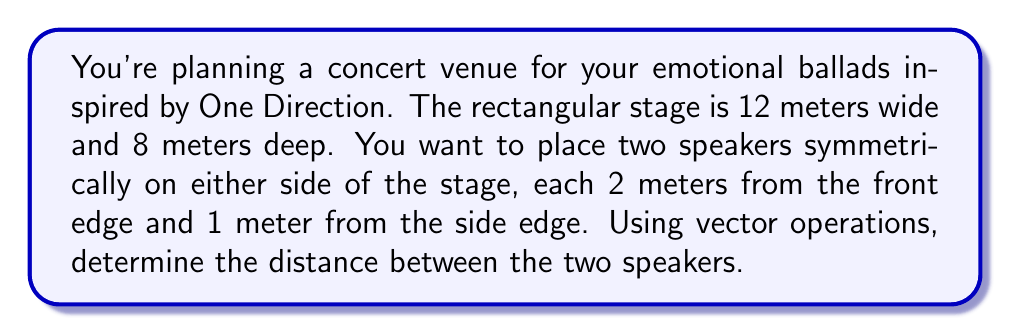Help me with this question. Let's approach this step-by-step using vector operations:

1) First, we need to define our coordinate system. Let's place the origin (0,0) at the front left corner of the stage.

2) Now, we can represent the positions of the two speakers as vectors:
   Left speaker: $\vec{v_1} = (1, 2)$
   Right speaker: $\vec{v_2} = (11, 2)$

3) To find the distance between the speakers, we need to find the vector that connects them:
   $\vec{d} = \vec{v_2} - \vec{v_1} = (11, 2) - (1, 2) = (10, 0)$

4) The magnitude of this vector will give us the distance. We can calculate this using the Euclidean norm:

   $$\|\vec{d}\| = \sqrt{d_x^2 + d_y^2} = \sqrt{10^2 + 0^2} = \sqrt{100} = 10$$

Therefore, the distance between the two speakers is 10 meters.
Answer: 10 meters 